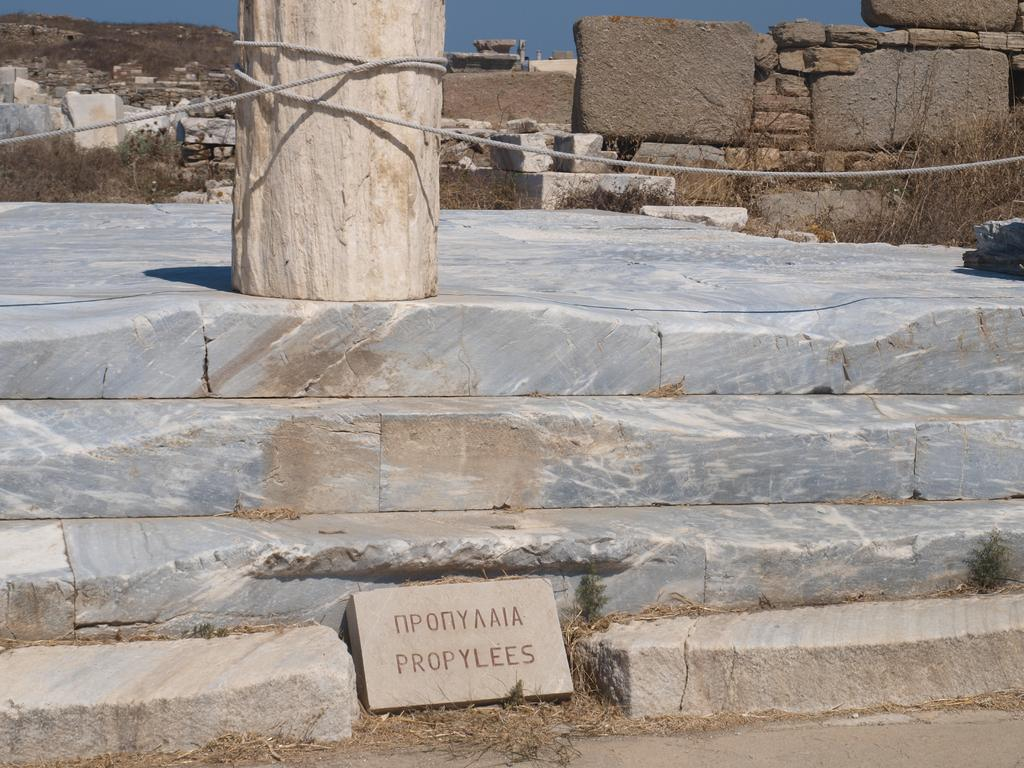What is located at the bottom of the image? There are stairs at the bottom of the image. What can be seen at the top of the image? There is a wooden pole at the top of the image. What is connected to the wooden pole? A rope is attached to the wooden pole. What type of magic is being performed with the rope and wooden pole in the image? There is no magic being performed in the image; it simply shows a rope attached to a wooden pole. Can you tell me how many times the person sneezed while taking the picture? There is no person present in the image, and therefore no sneezing can be observed. 